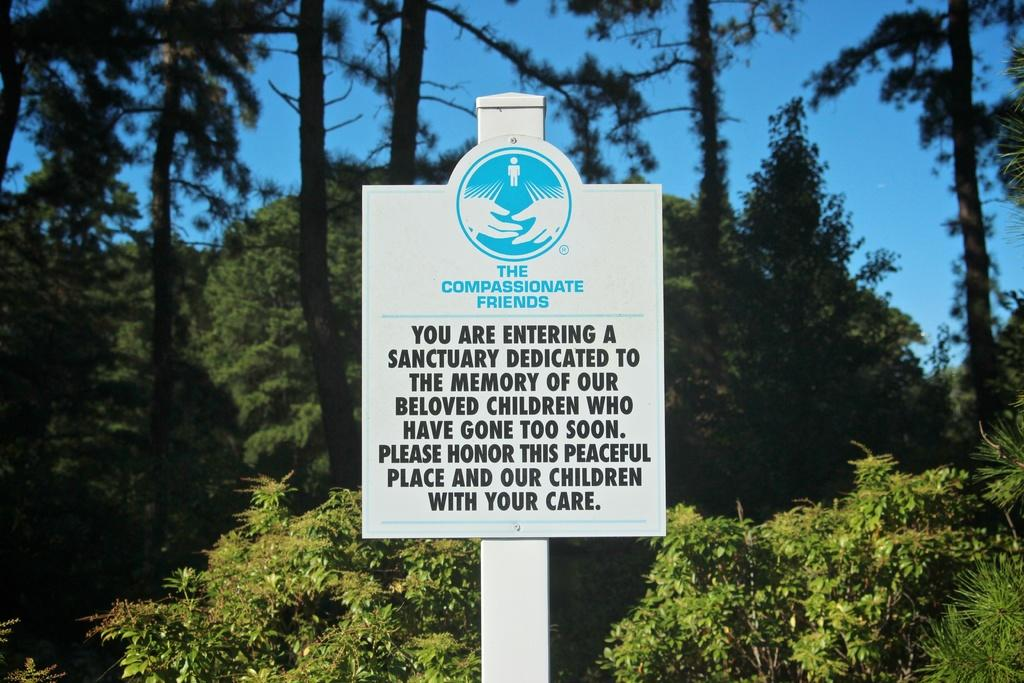What is on the board that is visible in the image? There is a board with text in the image. What type of natural vegetation can be seen in the image? There are trees visible in the image. What is visible in the sky in the image? The sky is visible in the image. What type of gold object is hanging from the trees in the image? There is no gold object hanging from the trees in the image. Can you see a carriage in the image? There is no carriage present in the image. Are there any mittens visible in the image? There are no mittens present in the image. 